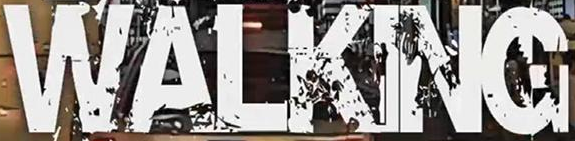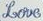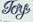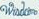What text is displayed in these images sequentially, separated by a semicolon? WALKING; Love; Toy; #### 